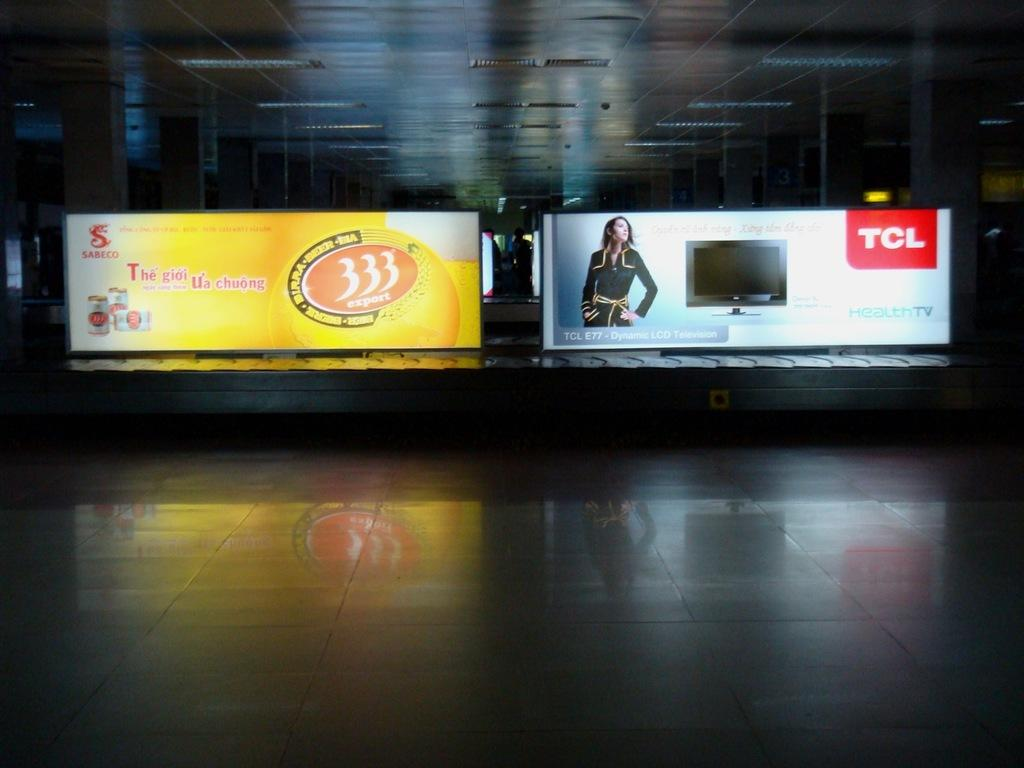Provide a one-sentence caption for the provided image. two billboards with the name tcl on it. 